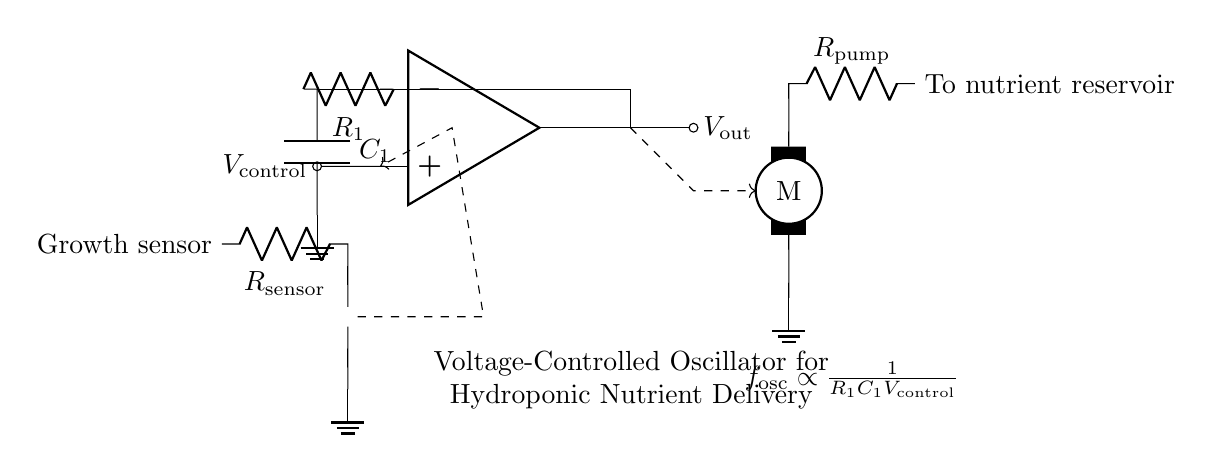What component is used for the voltage control? The voltage-controlled input of the circuit is represented by the node connected to the op-amp's non-inverting terminal, labeled V_control.
Answer: V_control What is the relationship of frequency oscillation to control voltage, resistance, and capacitance? The circuit shows that the frequency of oscillation, represented as f_osc, is inversely proportional to the product of resistance R1, capacitance C1, and control voltage V_control, as indicated in the label of the circuit.
Answer: f_osc ∝ 1/(R1C1V_control) What type of sensor is depicted in the circuit? The circuit displays a growth sensor, represented by a thermistor symbol, which is connected to a resistor R_sensor.
Answer: Growth sensor How does the oscillator output affect the nutrient pump? The output from the oscillator, V_out, is connected via a dashed line to the nutrient pump, indicating that V_out modulates the pump operation based on the changing nutrient delivery rates influenced by plant growth metrics.
Answer: Modulates What is the role of the capacitor in this circuit? The capacitor C1 in the feedback loop helps to determine the timing characteristics and frequency of oscillation by providing a charge/discharge cycle that influences the stability of the oscillator's output.
Answer: Timing characteristic What does the dashed arrow represent in the circuit diagram? The dashed arrows indicate the direction of control signals or the relationship between different components, such as the influence of the growth sensor on the op-amp input and the output driving the nutrient pump.
Answer: Control signals How does the resistance of the pump relate to the nutrient flow? The resistance R_pump in series with the nutrient pump influences the flow rate; higher resistance generally means lower flow rate, while lower resistance allows for greater nutrient delivery.
Answer: Influences flow rate 